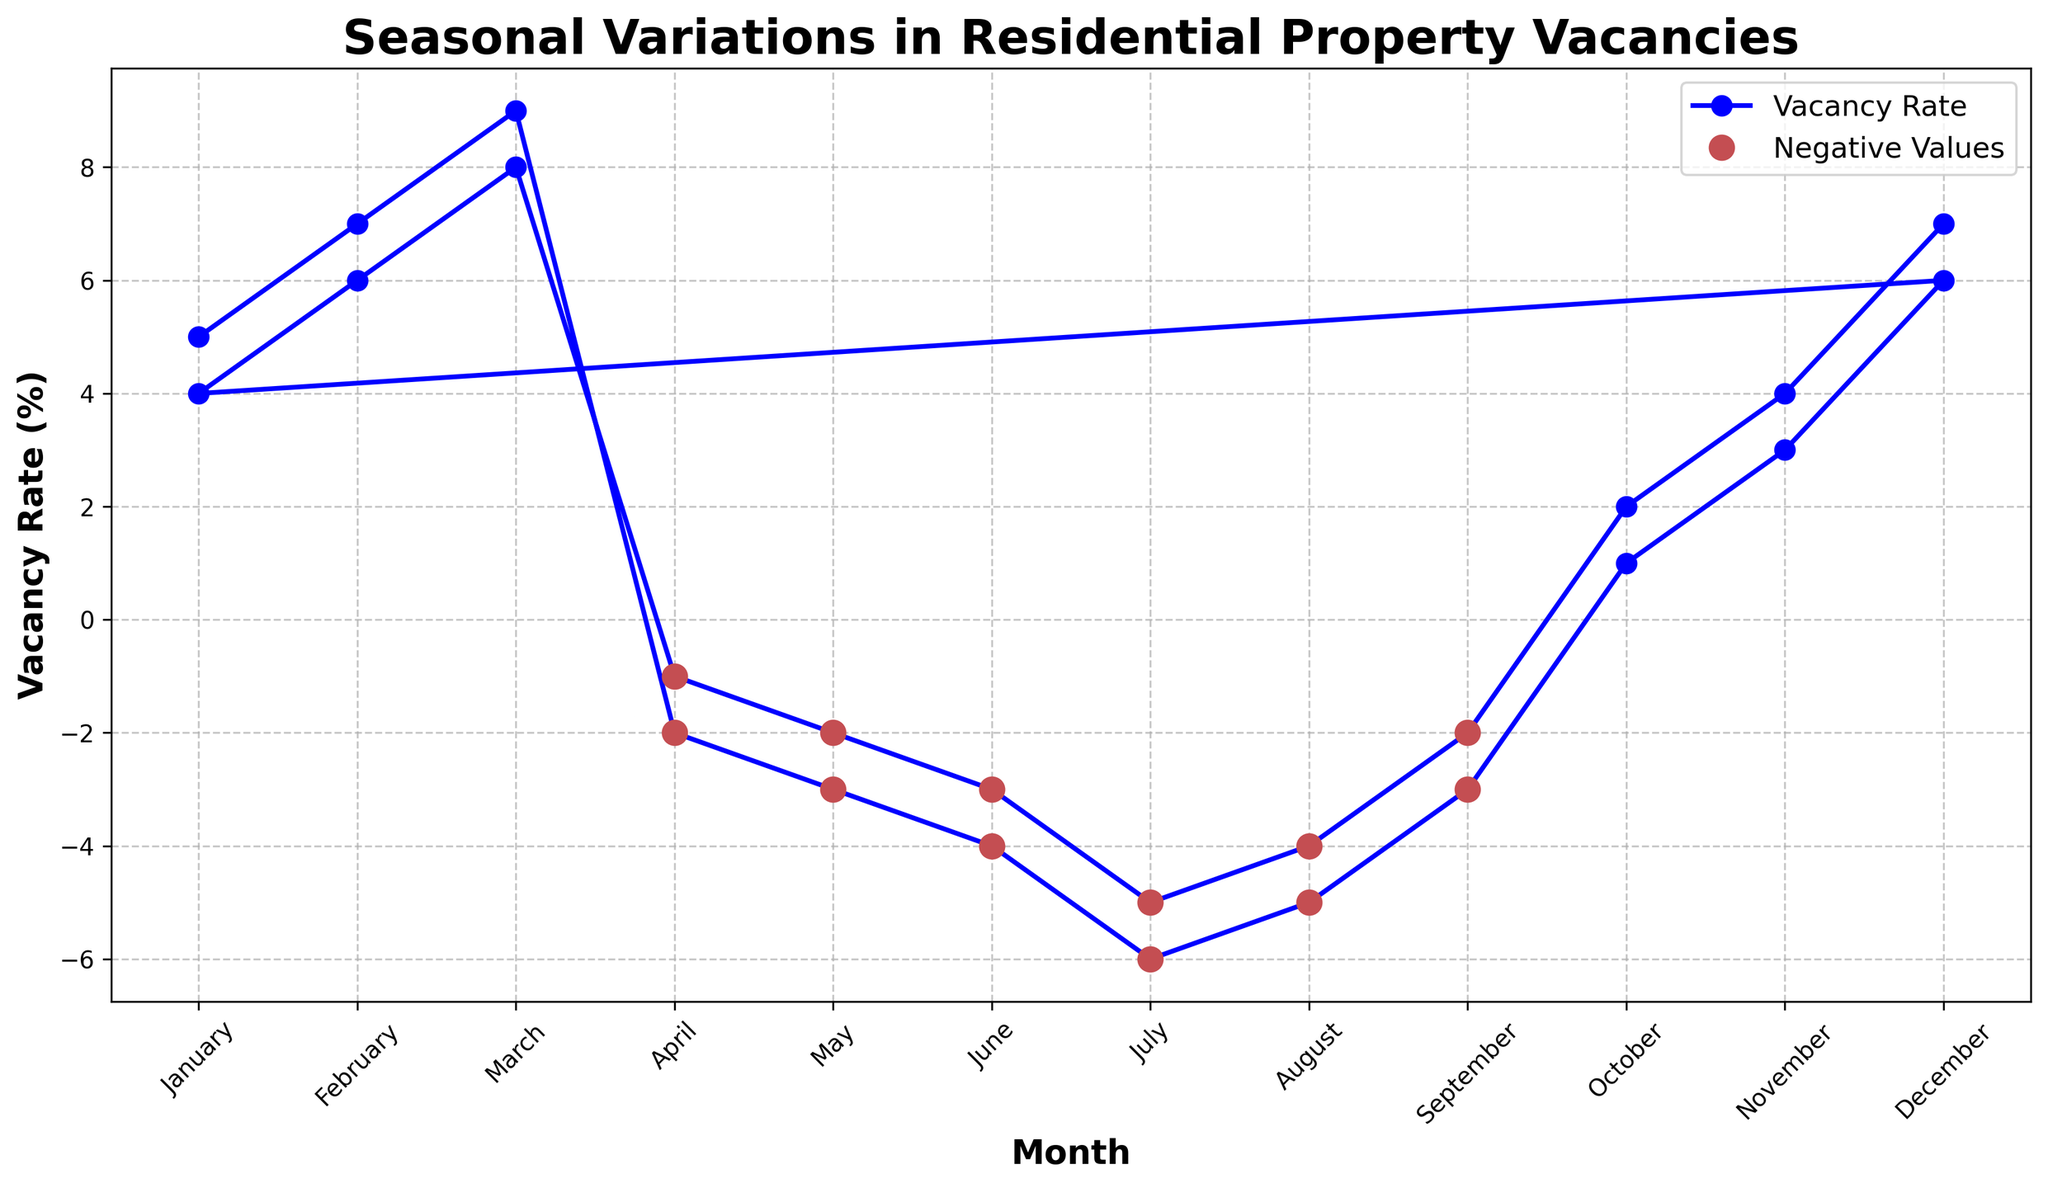Which month has the lowest vacancy rate? From the plot, the lowest point on the vertical axis marks the minimum value of the vacancy rate. This is in July with a rate of -6%.
Answer: July How many months have a negative vacancy rate? Identify the number of points below the horizontal axis (0%), which represent the negative values. There are nine such months.
Answer: Nine What is the average vacancy rate for the months with positive values? Locate the months with positive vacancy rates and sum their values: 5+7+9+1+3+6+4+6+8+2+4+7 = 62. There are 12 months with positive values, so the average is 62/12.
Answer: 5.17% Which month shows the largest increase in vacancy rate compared to the previous month? Examine the vertical distances between consecutive months. Between September to October, the rate jumps from -2% to 2%, an increase of 4%. This is the largest increase.
Answer: October What is the range of the vacancy rates throughout the year? Find the difference between the maximum and minimum values of the vacancy rate. The maximum is 9% (March), and the minimum is -6% (July), so the range is 9-(-6) = 15%.
Answer: 15% Identify all the months ending with a negative vacancy rate. Check the final month of each visible year. The last month shown for each year is December, which both years end with positive rates (6% and 7%). No months end with a negative rate.
Answer: None What is the overall trend from January to December in the second year? Observe the line from the second January to December (rows 13 to 24), showing how it varies beginning high and ending high: January (4%) -> December (7%) indicates a general upward trend.
Answer: Upward Compare the vacancy rate in January of both years. Look at the values for January in both years depicted: the first January is at 5% while the second is 4%.
Answer: 2022 rolls over to 2023 end at a lower rate What is the combined vacancy rate for April and May in the first year? Add the vacancy rates for April (-2%) and May (-3%): -2 + (-3) = -5%.
Answer: -5% During which months do the vacancy rates dip below -4%? Identify the months with vacancy rates lower than -4%. Look at June and July in the first year with values -4% and -6%.
Answer: June and July 